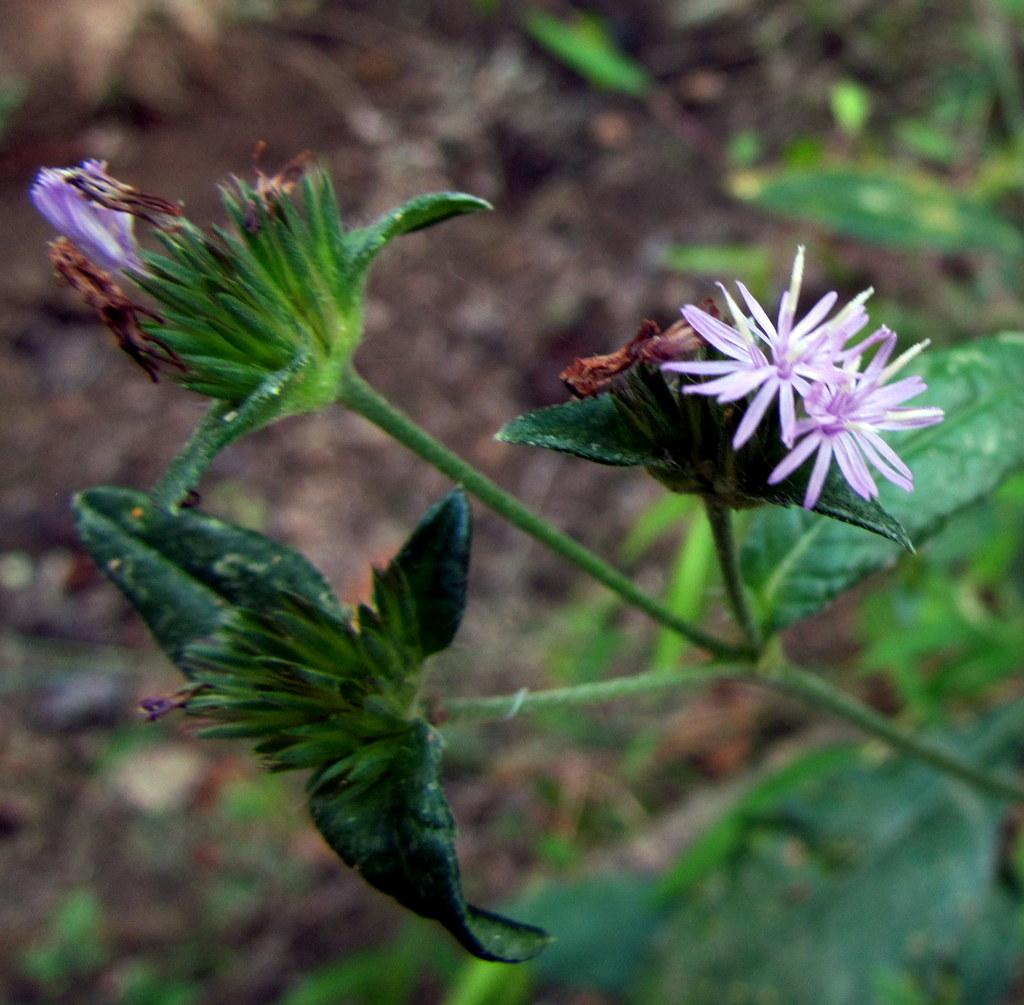What color are the flowers in the image? The flowers in the image are purple. Where are the flowers located? The flowers are on a plant. Can you describe the background of the image? The background of the image is blurred. What type of land can be seen in the image? There is no land visible in the image; it features a blurred background with purple flowers on a plant. 